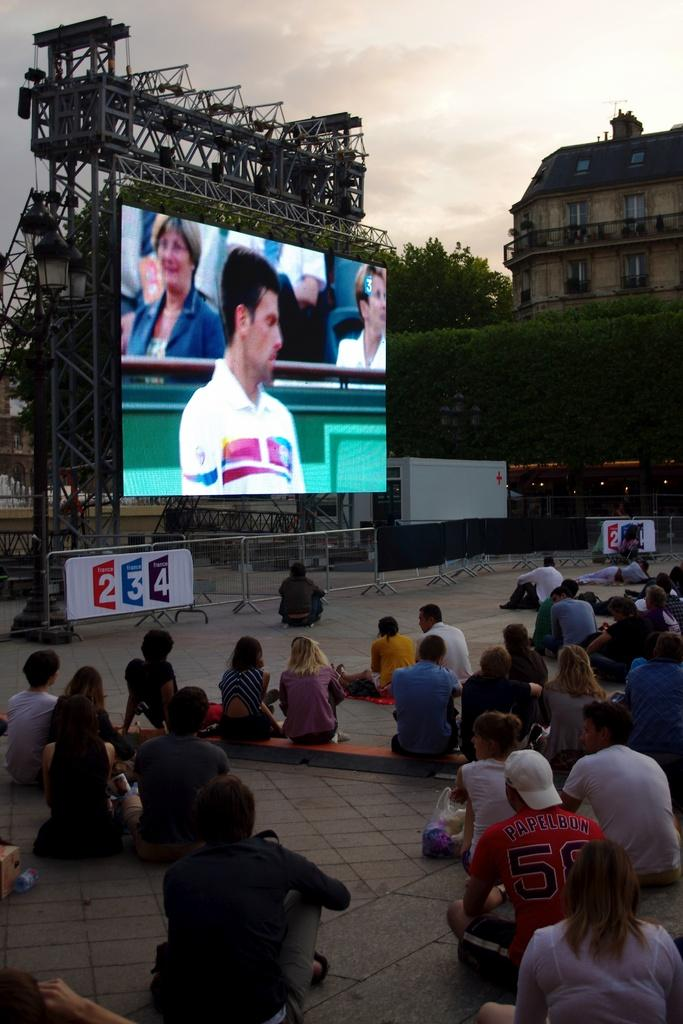Provide a one-sentence caption for the provided image. A large screen sponsored by France 234 shows a game being played to a crowd sitting around it. 